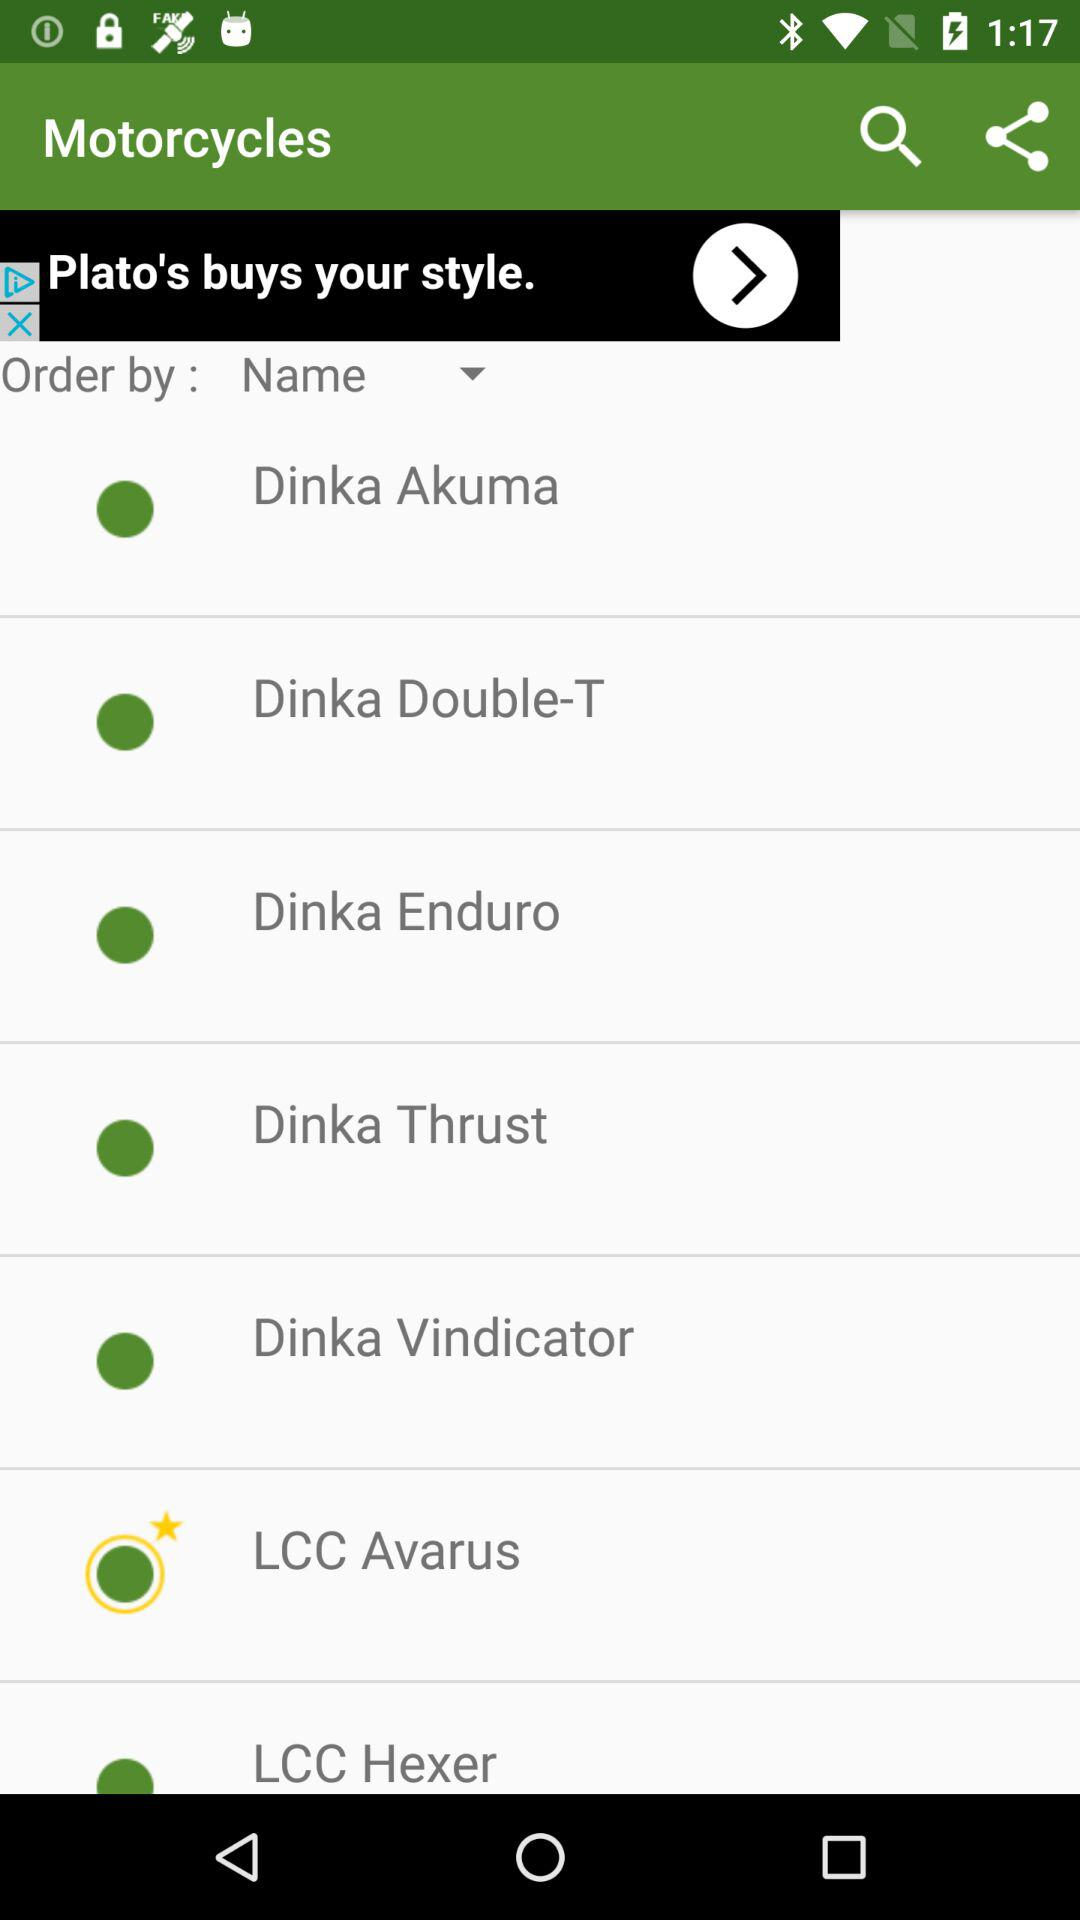What is selected for "Order by"? For "Order by", "Name" is selected. 